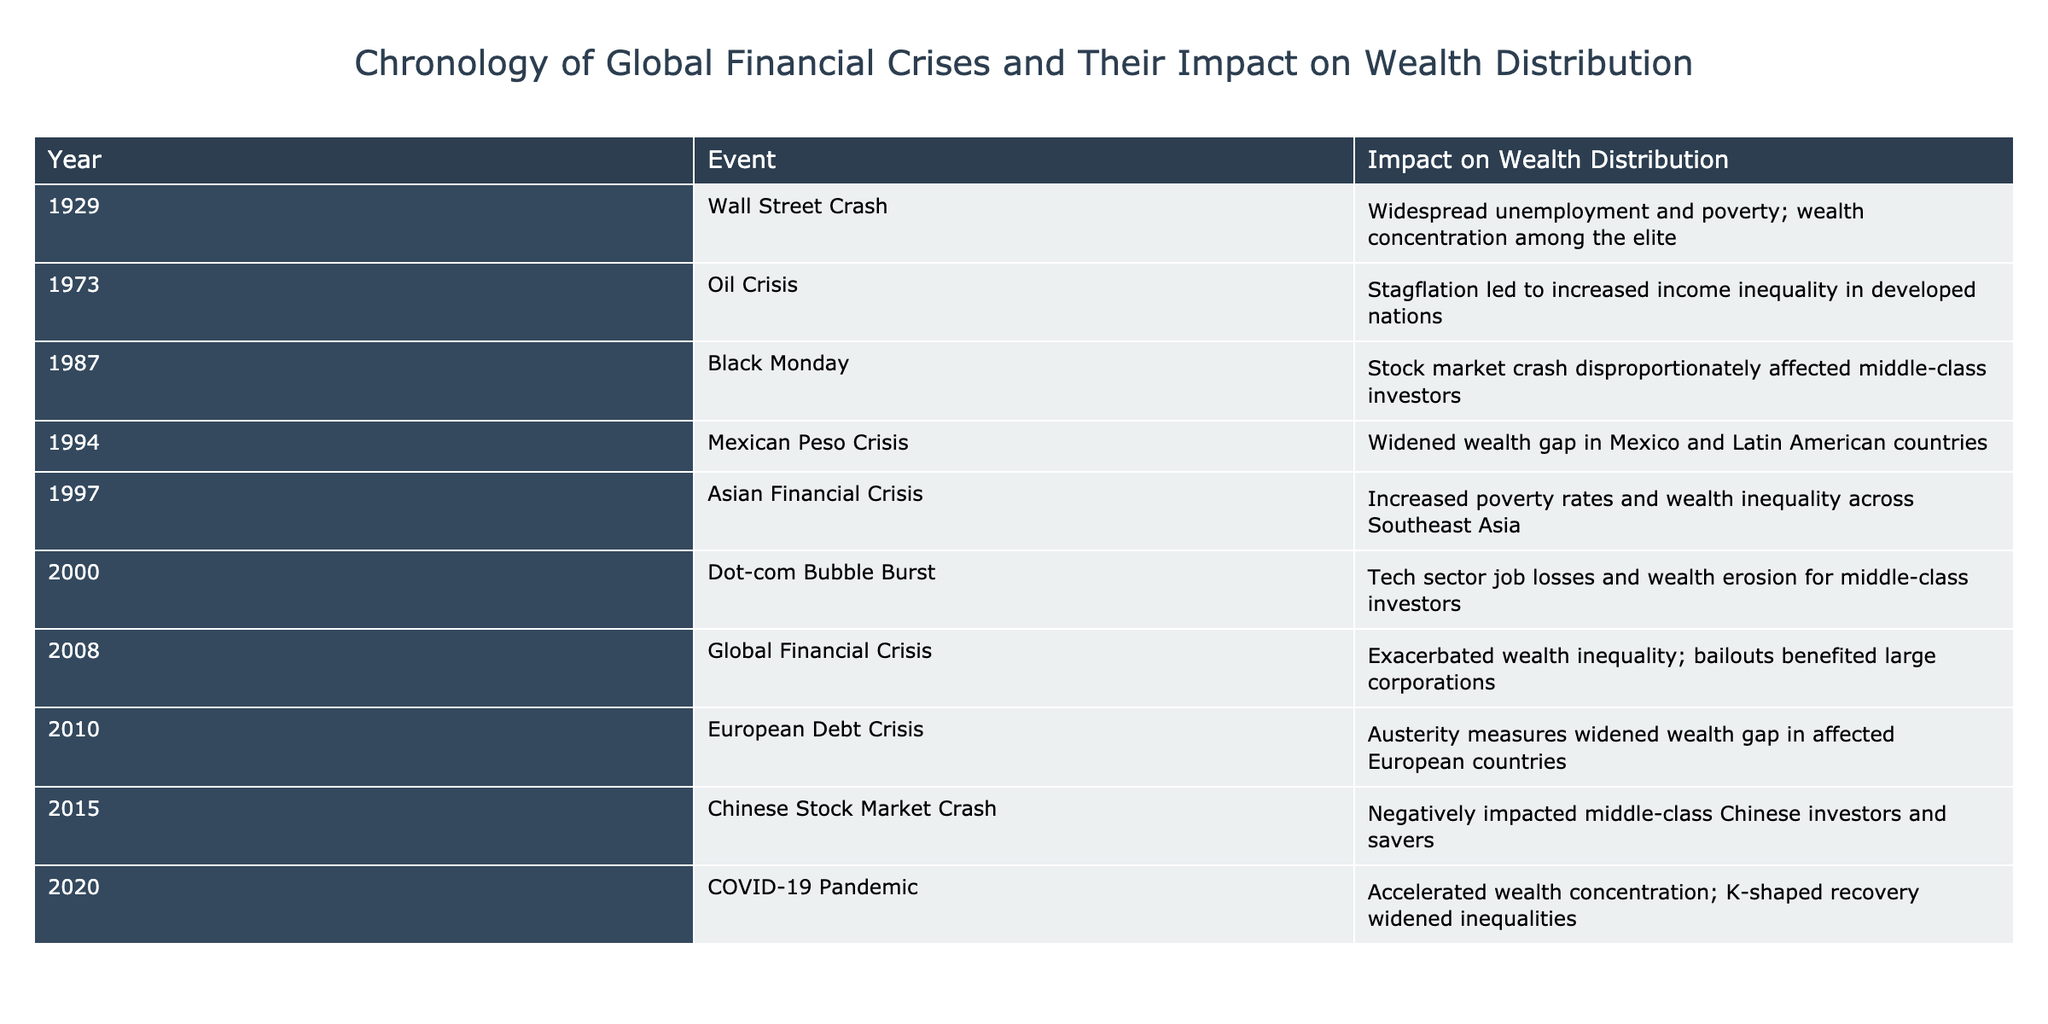What year did the Global Financial Crisis occur? The table lists the events chronologically, and the Global Financial Crisis is marked in the year 2008.
Answer: 2008 Which event resulted in increased income inequality in developed nations? Referring to the impact column for the event in 1973, it states that the Oil Crisis led to increased income inequality in developed nations.
Answer: Oil Crisis What was the impact on wealth distribution of the Asian Financial Crisis? The Asian Financial Crisis, recorded in 1997, is noted to have increased poverty rates and wealth inequality across Southeast Asia.
Answer: Increased poverty rates and wealth inequality Did the COVID-19 Pandemic exacerbate wealth concentration? The table shows that the impact of the COVID-19 Pandemic in 2020 accelerated wealth concentration, indicating a true statement about this event's effect.
Answer: Yes What was the average time span between the financial crises listed in the table? There are 9 events recorded in the table from 1929 to 2020, which spans 91 years. By finding the average span (91 years/8 gaps) gives approximately 11.375 years between crises.
Answer: About 11.4 years Which crisis caused the middle-class investors to be disproportionately affected? Looking at the listed events, the Black Monday event in 1987 specifically mentions that middle-class investors were disproportionately affected during that stock market crash.
Answer: Black Monday For which events did the effects on wealth distribution lead to widening the wealth gap? The table shows that both the Global Financial Crisis in 2008 and the European Debt Crisis in 2010 had impacts that resulted in widening wealth gaps, suggesting these two events share this outcome.
Answer: Global Financial Crisis and European Debt Crisis How many events mentioned had a negative impact specifically on middle-class investors? By reviewing the events referencing middle-class investors, the Black Monday in 1987 and the Chinese Stock Market Crash in 2015 show impacts specifically noted. Thus, there are two events.
Answer: 2 events What was the main outcome of the Dot-com Bubble Burst? The Dot-com Bubble Burst in 2000 is noted for causing tech sector job losses and wealth erosion for middle-class investors, summarizing its primary outcomes effectively.
Answer: Tech sector job losses and wealth erosion for middle-class investors 